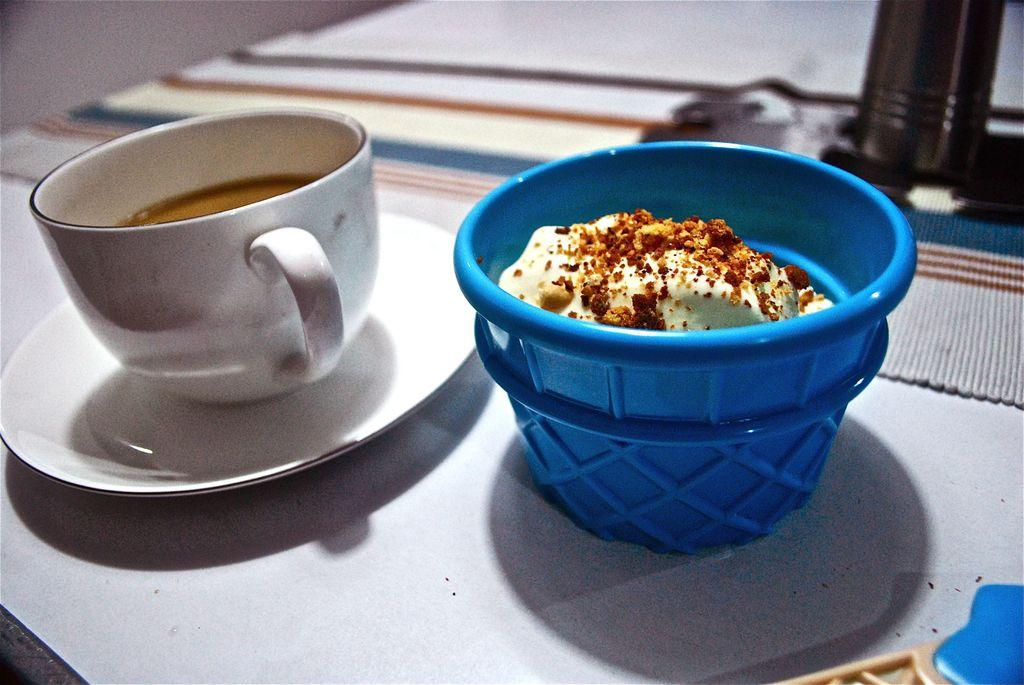What is in the cup that is visible in the image? There is a cup with liquid in the image. What is supporting the cup in the image? There is a saucer under the cup. What is in the bowl that is visible in the image? There is a bowl with food in the image. What type of material is present in the image? There is a cloth in the image. Can you describe any other objects in the image? A: There are other unspecified objects in the image. What type of park is visible in the image? There is no park present in the image. What is the mass of the arm in the image? There is no arm present in the image. 